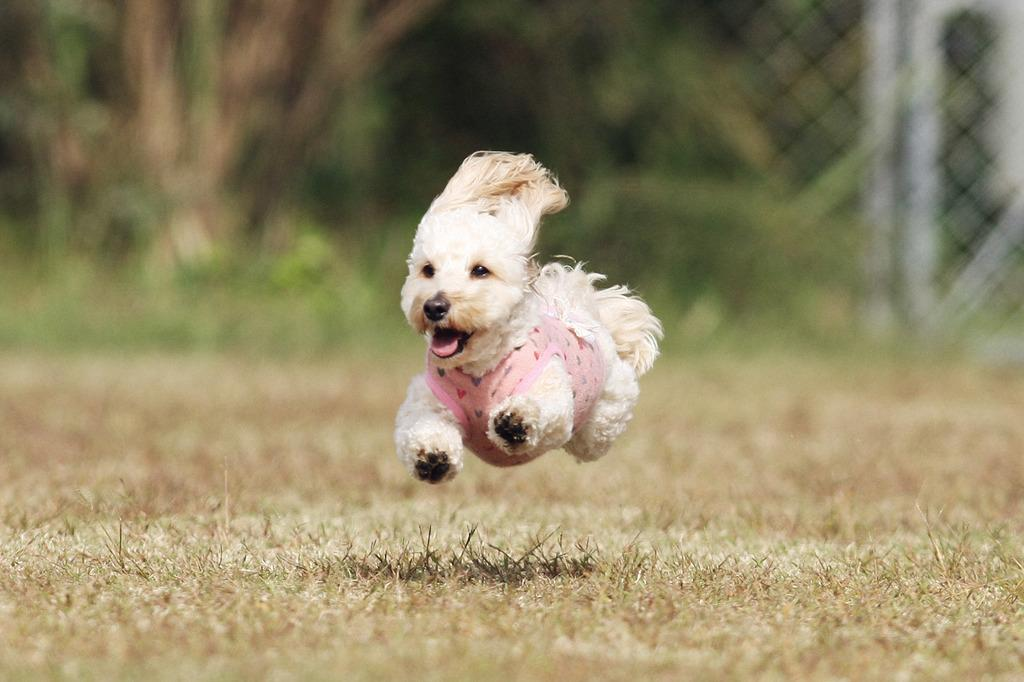What type of animal is in the image? There is a white dog in the image. What is the dog doing in the image? The dog is running on the ground. What is the dog wearing in the image? The dog is wearing a pink dress. What can be seen in the background of the image? There are trees, plants, and grass in the background of the image. What type of sugar can be seen in the image? There is no sugar present in the image; it features a white dog running on the ground while wearing a pink dress. How many boats are visible in the image? There are no boats present in the image. 